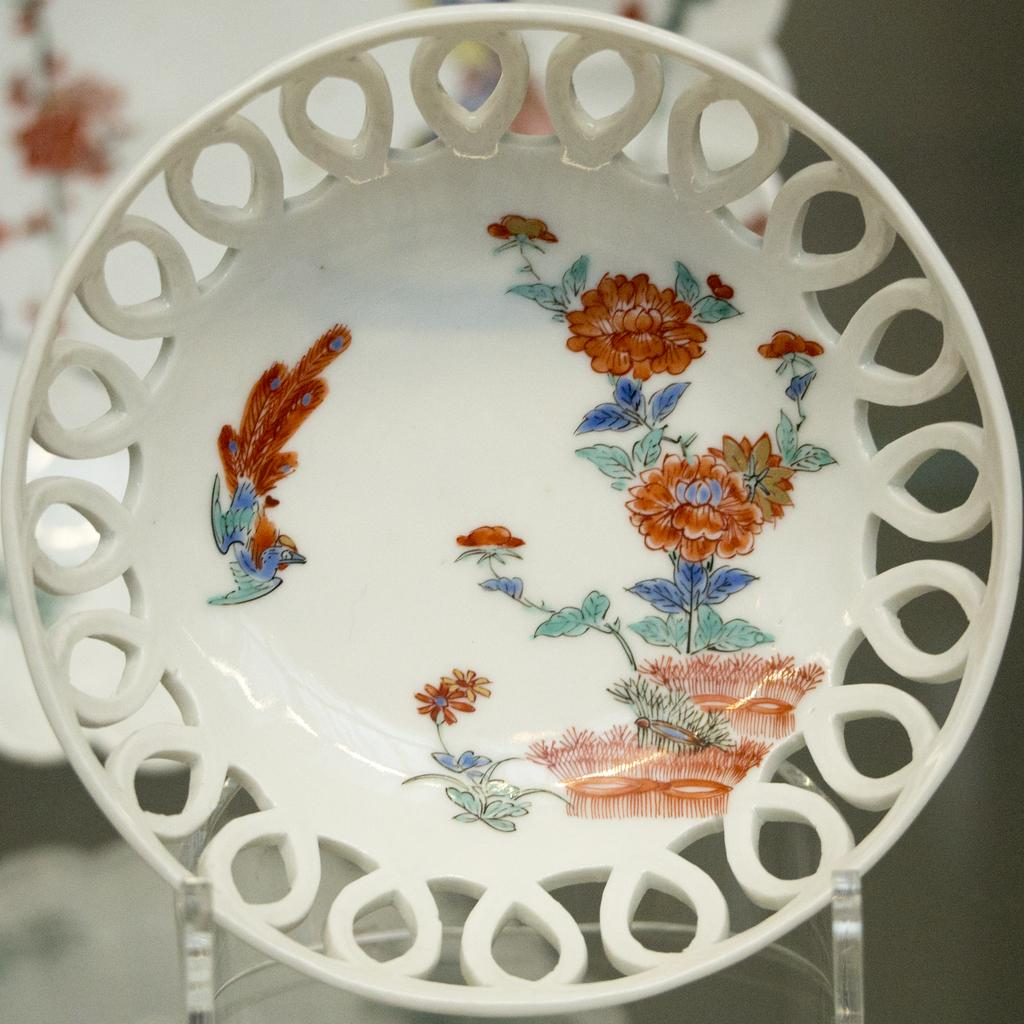What object is present on a stand in the image? There is a plate in the image, and it is on a stand. What colors can be seen on the plate? The plate has white, green, brown, and blue colors. How would you describe the background of the image? The background of the image is blurred. How many bikes are leaning against the plate in the image? There are no bikes present in the image; it only features a plate on a stand. What is the desire of the plate in the image? The plate is an inanimate object and does not have desires. 